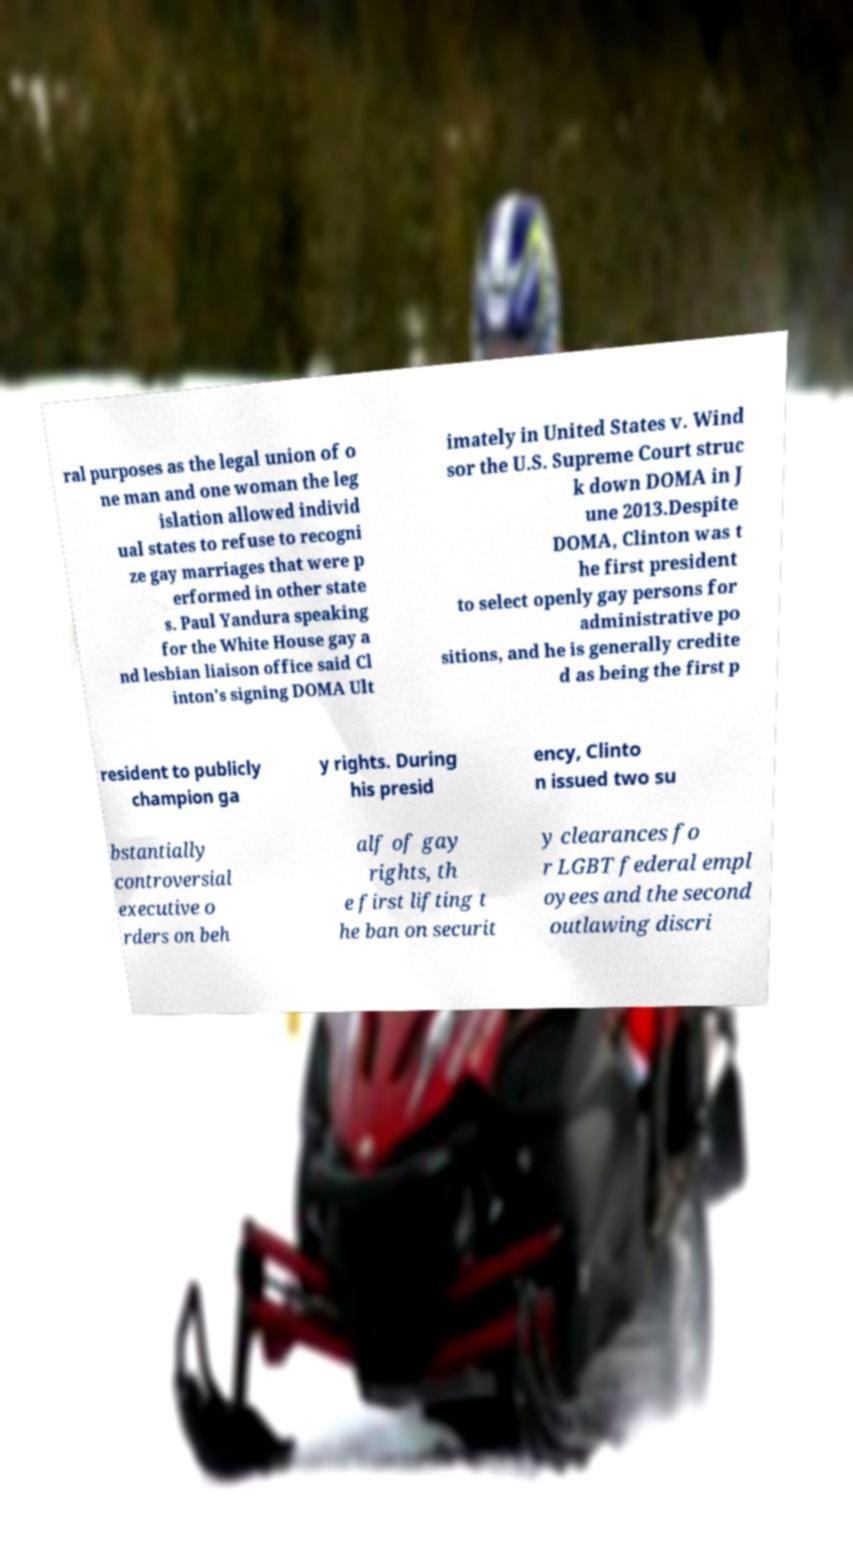Could you assist in decoding the text presented in this image and type it out clearly? ral purposes as the legal union of o ne man and one woman the leg islation allowed individ ual states to refuse to recogni ze gay marriages that were p erformed in other state s. Paul Yandura speaking for the White House gay a nd lesbian liaison office said Cl inton's signing DOMA Ult imately in United States v. Wind sor the U.S. Supreme Court struc k down DOMA in J une 2013.Despite DOMA, Clinton was t he first president to select openly gay persons for administrative po sitions, and he is generally credite d as being the first p resident to publicly champion ga y rights. During his presid ency, Clinto n issued two su bstantially controversial executive o rders on beh alf of gay rights, th e first lifting t he ban on securit y clearances fo r LGBT federal empl oyees and the second outlawing discri 